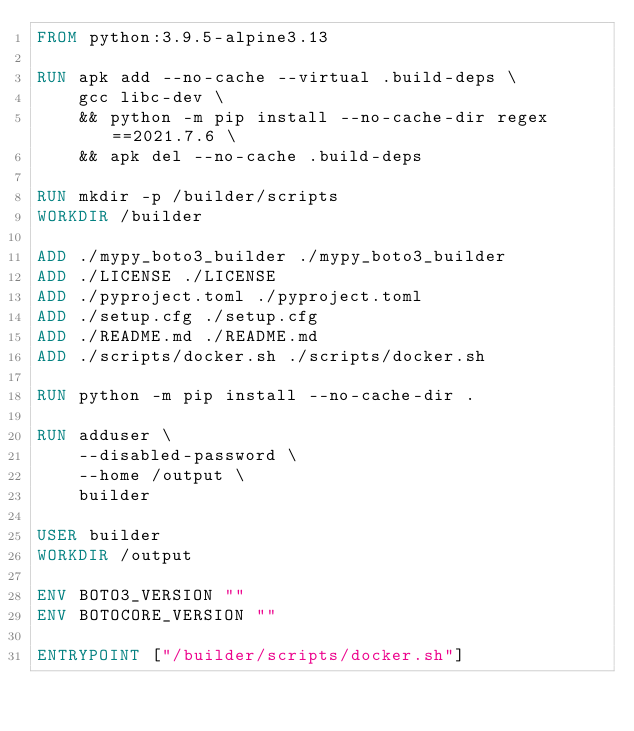<code> <loc_0><loc_0><loc_500><loc_500><_Dockerfile_>FROM python:3.9.5-alpine3.13

RUN apk add --no-cache --virtual .build-deps \
    gcc libc-dev \
    && python -m pip install --no-cache-dir regex==2021.7.6 \
    && apk del --no-cache .build-deps

RUN mkdir -p /builder/scripts
WORKDIR /builder

ADD ./mypy_boto3_builder ./mypy_boto3_builder
ADD ./LICENSE ./LICENSE
ADD ./pyproject.toml ./pyproject.toml
ADD ./setup.cfg ./setup.cfg
ADD ./README.md ./README.md
ADD ./scripts/docker.sh ./scripts/docker.sh

RUN python -m pip install --no-cache-dir .

RUN adduser \
    --disabled-password \
    --home /output \
    builder

USER builder
WORKDIR /output

ENV BOTO3_VERSION ""
ENV BOTOCORE_VERSION ""

ENTRYPOINT ["/builder/scripts/docker.sh"]
</code> 